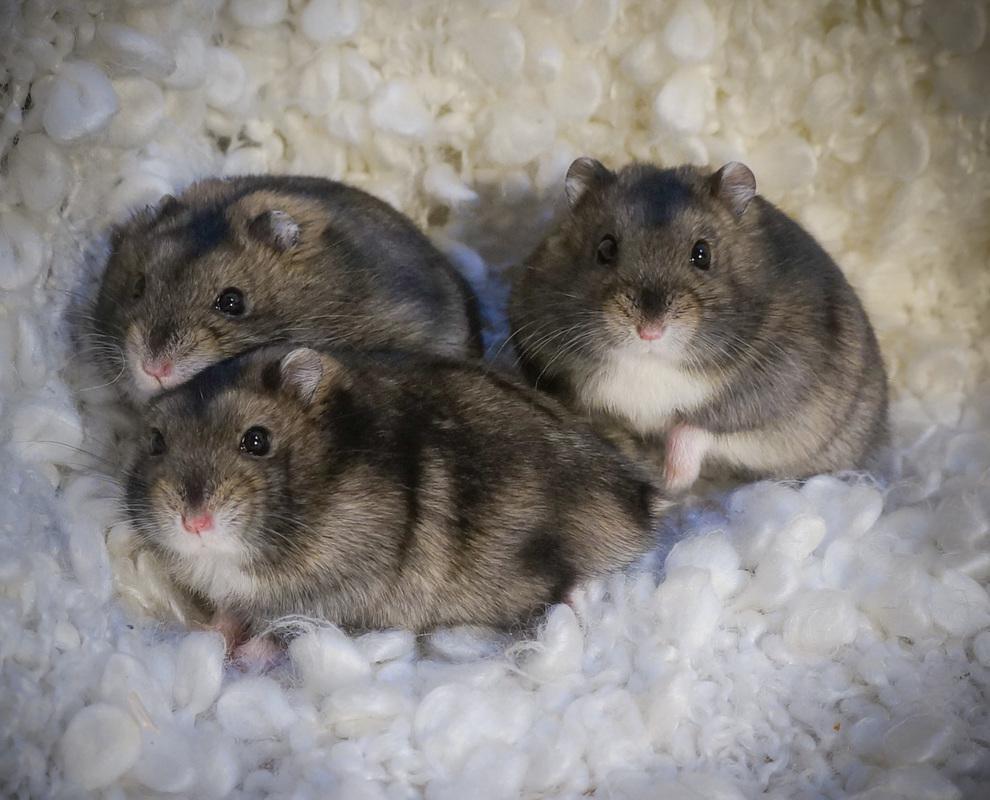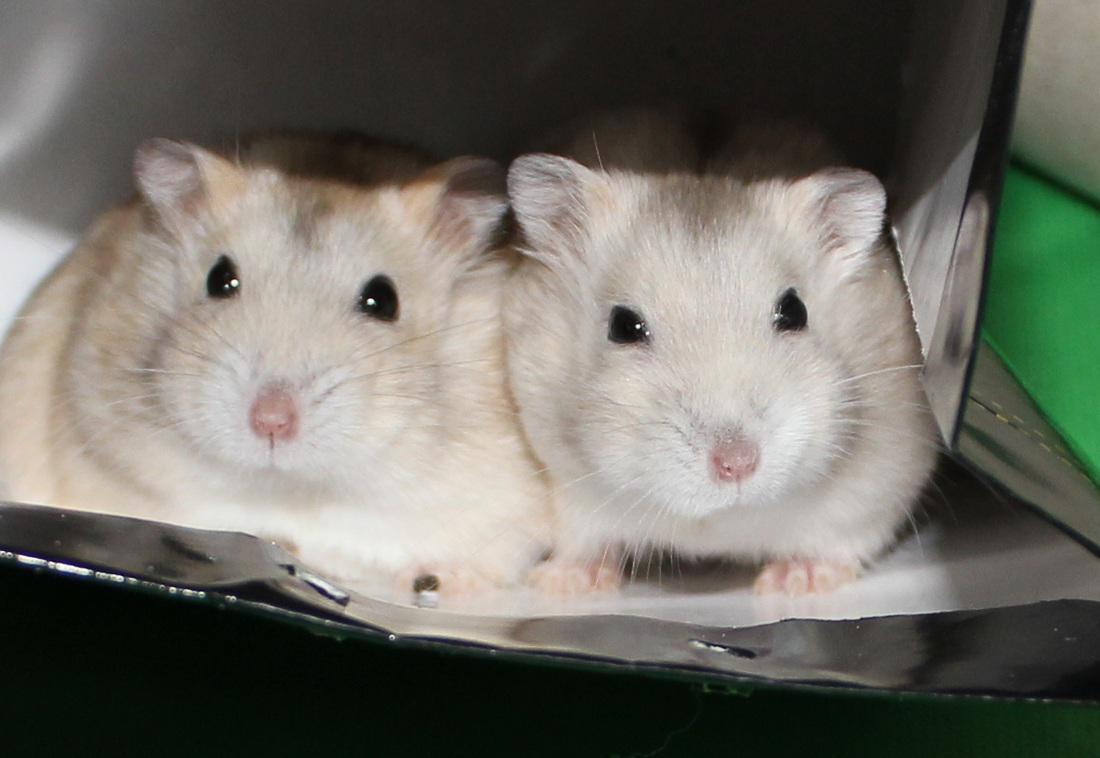The first image is the image on the left, the second image is the image on the right. Given the left and right images, does the statement "at least one hamster in on wood shavings" hold true? Answer yes or no. No. The first image is the image on the left, the second image is the image on the right. Assess this claim about the two images: "There are 2 white mice next to each other.". Correct or not? Answer yes or no. Yes. 